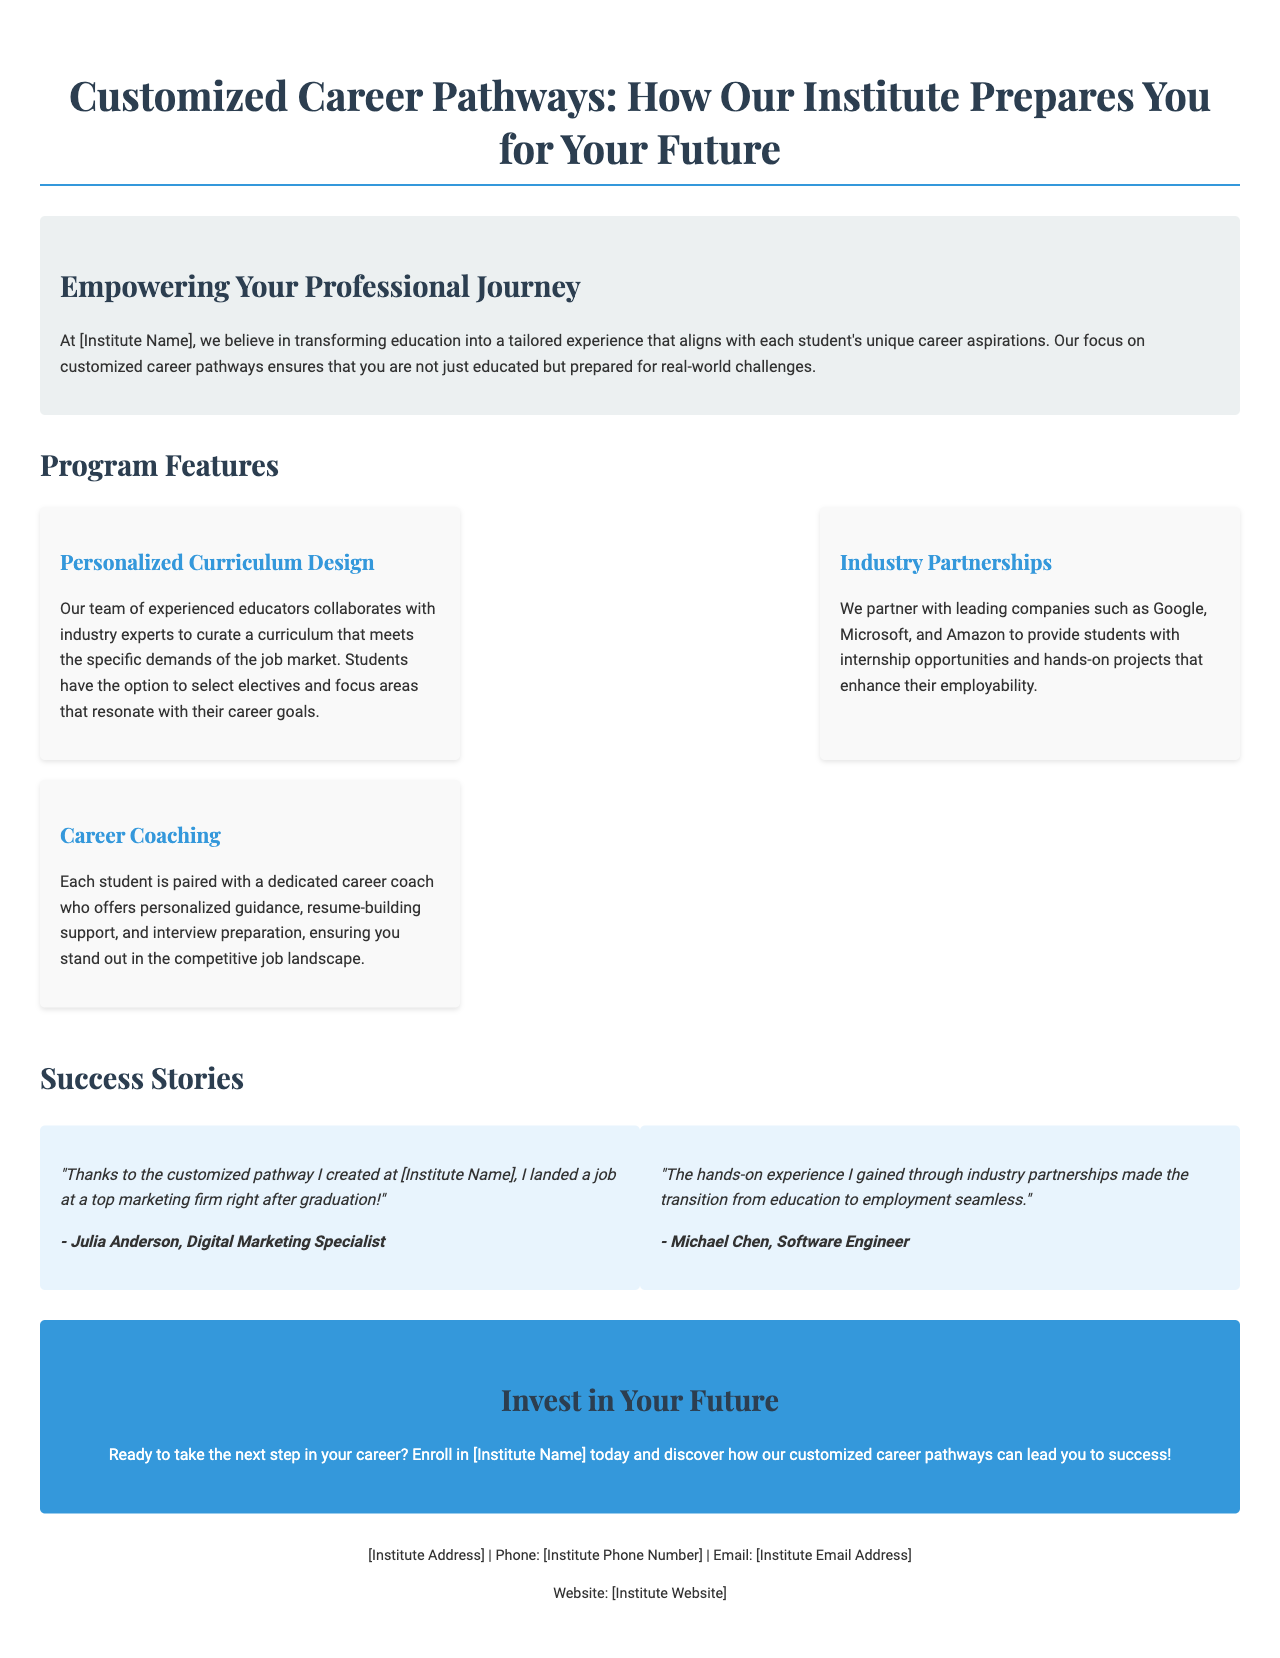what is the title of the document? The title is prominently displayed at the top of the document.
Answer: Customized Career Pathways: How Our Institute Prepares You for Your Future who is the target audience for this institute's program? The audience is implied through the language and context of the document, indicating potential students.
Answer: Students which companies are mentioned as industry partners? The partnerships with specific companies are listed under the Industry Partnerships section.
Answer: Google, Microsoft, Amazon what type of support do students receive from career coaches? This information is provided in the Career Coaching section outlining the specific support mechanisms.
Answer: Personalized guidance, resume-building support, interview preparation what is one success story highlighted in the testimonials? Two success stories are provided, indicating the effectiveness of the program.
Answer: Julia Anderson, Digital Marketing Specialist how does the institute ensure a tailored educational experience? This is explained in the Personalized Curriculum Design feature of the document.
Answer: Customized career pathways what call to action is presented at the end of the document? The call to action is the concluding statement encouraging enrollment.
Answer: Enroll in [Institute Name] today what color is used for the primary call to action section? The color is mentioned in the styling of the call to action block.
Answer: Blue what is the layout style of the testimonials section? The arrangement of items in this section is described to showcase testimonials.
Answer: Flex display 